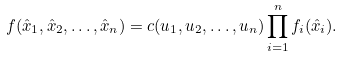Convert formula to latex. <formula><loc_0><loc_0><loc_500><loc_500>f ( \hat { x } _ { 1 } , \hat { x } _ { 2 } , \dots , \hat { x } _ { n } ) = c ( u _ { 1 } , u _ { 2 } , \dots , u _ { n } ) \prod _ { i = 1 } ^ { n } f _ { i } ( \hat { x } _ { i } ) .</formula> 